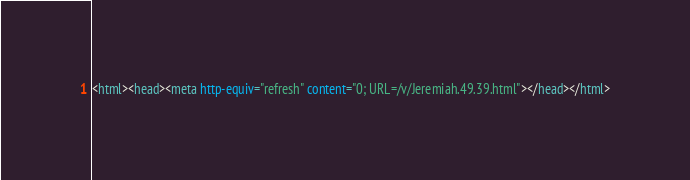Convert code to text. <code><loc_0><loc_0><loc_500><loc_500><_HTML_><html><head><meta http-equiv="refresh" content="0; URL=/v/Jeremiah.49.39.html"></head></html></code> 